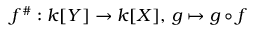<formula> <loc_0><loc_0><loc_500><loc_500>f ^ { \# } \colon k [ Y ] \to k [ X ] , \, g \mapsto g \circ f</formula> 